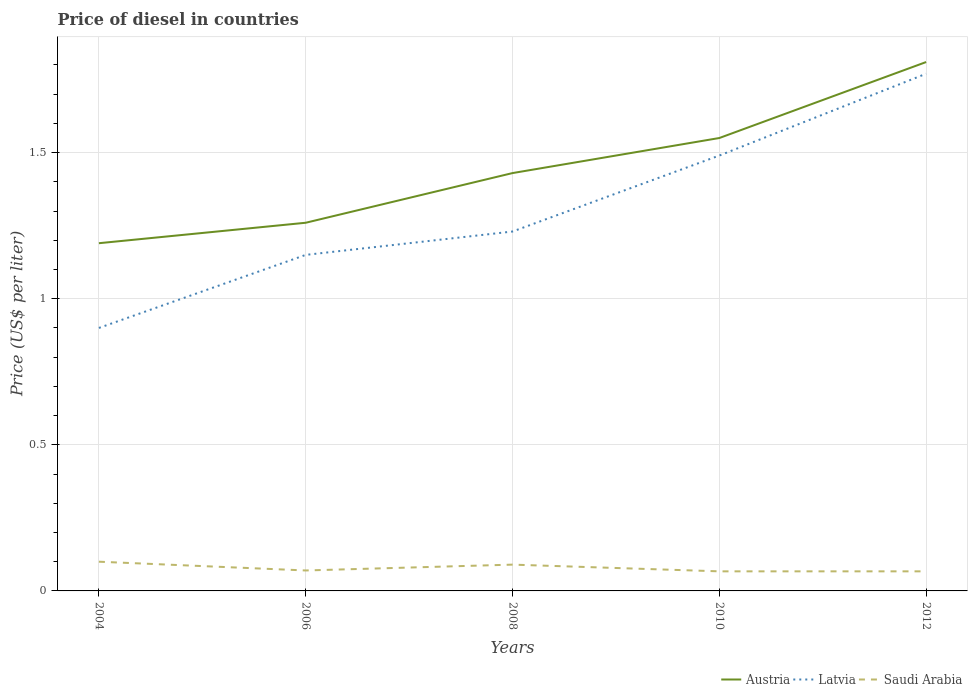How many different coloured lines are there?
Your response must be concise. 3. Does the line corresponding to Austria intersect with the line corresponding to Latvia?
Your answer should be compact. No. Is the number of lines equal to the number of legend labels?
Provide a succinct answer. Yes. Across all years, what is the maximum price of diesel in Saudi Arabia?
Make the answer very short. 0.07. In which year was the price of diesel in Latvia maximum?
Keep it short and to the point. 2004. What is the total price of diesel in Austria in the graph?
Your answer should be compact. -0.62. What is the difference between the highest and the second highest price of diesel in Saudi Arabia?
Offer a terse response. 0.03. What is the difference between the highest and the lowest price of diesel in Austria?
Your answer should be compact. 2. Is the price of diesel in Latvia strictly greater than the price of diesel in Austria over the years?
Offer a terse response. Yes. How many lines are there?
Your answer should be very brief. 3. What is the difference between two consecutive major ticks on the Y-axis?
Offer a terse response. 0.5. Are the values on the major ticks of Y-axis written in scientific E-notation?
Your response must be concise. No. Does the graph contain grids?
Offer a very short reply. Yes. Where does the legend appear in the graph?
Ensure brevity in your answer.  Bottom right. What is the title of the graph?
Provide a succinct answer. Price of diesel in countries. What is the label or title of the Y-axis?
Provide a succinct answer. Price (US$ per liter). What is the Price (US$ per liter) in Austria in 2004?
Your answer should be very brief. 1.19. What is the Price (US$ per liter) in Saudi Arabia in 2004?
Provide a succinct answer. 0.1. What is the Price (US$ per liter) in Austria in 2006?
Your answer should be very brief. 1.26. What is the Price (US$ per liter) of Latvia in 2006?
Keep it short and to the point. 1.15. What is the Price (US$ per liter) of Saudi Arabia in 2006?
Make the answer very short. 0.07. What is the Price (US$ per liter) in Austria in 2008?
Offer a very short reply. 1.43. What is the Price (US$ per liter) of Latvia in 2008?
Offer a very short reply. 1.23. What is the Price (US$ per liter) in Saudi Arabia in 2008?
Your answer should be very brief. 0.09. What is the Price (US$ per liter) of Austria in 2010?
Offer a very short reply. 1.55. What is the Price (US$ per liter) in Latvia in 2010?
Offer a very short reply. 1.49. What is the Price (US$ per liter) in Saudi Arabia in 2010?
Offer a very short reply. 0.07. What is the Price (US$ per liter) in Austria in 2012?
Provide a short and direct response. 1.81. What is the Price (US$ per liter) of Latvia in 2012?
Your response must be concise. 1.77. What is the Price (US$ per liter) of Saudi Arabia in 2012?
Your answer should be very brief. 0.07. Across all years, what is the maximum Price (US$ per liter) of Austria?
Your answer should be compact. 1.81. Across all years, what is the maximum Price (US$ per liter) of Latvia?
Your response must be concise. 1.77. Across all years, what is the minimum Price (US$ per liter) of Austria?
Provide a succinct answer. 1.19. Across all years, what is the minimum Price (US$ per liter) of Saudi Arabia?
Provide a short and direct response. 0.07. What is the total Price (US$ per liter) in Austria in the graph?
Offer a terse response. 7.24. What is the total Price (US$ per liter) in Latvia in the graph?
Make the answer very short. 6.54. What is the total Price (US$ per liter) of Saudi Arabia in the graph?
Your answer should be compact. 0.39. What is the difference between the Price (US$ per liter) of Austria in 2004 and that in 2006?
Your response must be concise. -0.07. What is the difference between the Price (US$ per liter) of Saudi Arabia in 2004 and that in 2006?
Your response must be concise. 0.03. What is the difference between the Price (US$ per liter) in Austria in 2004 and that in 2008?
Give a very brief answer. -0.24. What is the difference between the Price (US$ per liter) of Latvia in 2004 and that in 2008?
Keep it short and to the point. -0.33. What is the difference between the Price (US$ per liter) in Saudi Arabia in 2004 and that in 2008?
Ensure brevity in your answer.  0.01. What is the difference between the Price (US$ per liter) in Austria in 2004 and that in 2010?
Your answer should be compact. -0.36. What is the difference between the Price (US$ per liter) in Latvia in 2004 and that in 2010?
Give a very brief answer. -0.59. What is the difference between the Price (US$ per liter) in Saudi Arabia in 2004 and that in 2010?
Ensure brevity in your answer.  0.03. What is the difference between the Price (US$ per liter) of Austria in 2004 and that in 2012?
Make the answer very short. -0.62. What is the difference between the Price (US$ per liter) of Latvia in 2004 and that in 2012?
Offer a terse response. -0.87. What is the difference between the Price (US$ per liter) in Saudi Arabia in 2004 and that in 2012?
Give a very brief answer. 0.03. What is the difference between the Price (US$ per liter) in Austria in 2006 and that in 2008?
Ensure brevity in your answer.  -0.17. What is the difference between the Price (US$ per liter) in Latvia in 2006 and that in 2008?
Keep it short and to the point. -0.08. What is the difference between the Price (US$ per liter) of Saudi Arabia in 2006 and that in 2008?
Your answer should be very brief. -0.02. What is the difference between the Price (US$ per liter) of Austria in 2006 and that in 2010?
Offer a very short reply. -0.29. What is the difference between the Price (US$ per liter) of Latvia in 2006 and that in 2010?
Your response must be concise. -0.34. What is the difference between the Price (US$ per liter) in Saudi Arabia in 2006 and that in 2010?
Your answer should be very brief. 0. What is the difference between the Price (US$ per liter) of Austria in 2006 and that in 2012?
Give a very brief answer. -0.55. What is the difference between the Price (US$ per liter) of Latvia in 2006 and that in 2012?
Your answer should be compact. -0.62. What is the difference between the Price (US$ per liter) in Saudi Arabia in 2006 and that in 2012?
Offer a very short reply. 0. What is the difference between the Price (US$ per liter) in Austria in 2008 and that in 2010?
Your answer should be compact. -0.12. What is the difference between the Price (US$ per liter) in Latvia in 2008 and that in 2010?
Ensure brevity in your answer.  -0.26. What is the difference between the Price (US$ per liter) of Saudi Arabia in 2008 and that in 2010?
Ensure brevity in your answer.  0.02. What is the difference between the Price (US$ per liter) of Austria in 2008 and that in 2012?
Make the answer very short. -0.38. What is the difference between the Price (US$ per liter) in Latvia in 2008 and that in 2012?
Provide a succinct answer. -0.54. What is the difference between the Price (US$ per liter) of Saudi Arabia in 2008 and that in 2012?
Keep it short and to the point. 0.02. What is the difference between the Price (US$ per liter) in Austria in 2010 and that in 2012?
Make the answer very short. -0.26. What is the difference between the Price (US$ per liter) of Latvia in 2010 and that in 2012?
Provide a succinct answer. -0.28. What is the difference between the Price (US$ per liter) in Austria in 2004 and the Price (US$ per liter) in Latvia in 2006?
Your response must be concise. 0.04. What is the difference between the Price (US$ per liter) in Austria in 2004 and the Price (US$ per liter) in Saudi Arabia in 2006?
Provide a succinct answer. 1.12. What is the difference between the Price (US$ per liter) in Latvia in 2004 and the Price (US$ per liter) in Saudi Arabia in 2006?
Make the answer very short. 0.83. What is the difference between the Price (US$ per liter) of Austria in 2004 and the Price (US$ per liter) of Latvia in 2008?
Give a very brief answer. -0.04. What is the difference between the Price (US$ per liter) of Austria in 2004 and the Price (US$ per liter) of Saudi Arabia in 2008?
Keep it short and to the point. 1.1. What is the difference between the Price (US$ per liter) in Latvia in 2004 and the Price (US$ per liter) in Saudi Arabia in 2008?
Your answer should be very brief. 0.81. What is the difference between the Price (US$ per liter) in Austria in 2004 and the Price (US$ per liter) in Saudi Arabia in 2010?
Offer a terse response. 1.12. What is the difference between the Price (US$ per liter) of Latvia in 2004 and the Price (US$ per liter) of Saudi Arabia in 2010?
Make the answer very short. 0.83. What is the difference between the Price (US$ per liter) in Austria in 2004 and the Price (US$ per liter) in Latvia in 2012?
Give a very brief answer. -0.58. What is the difference between the Price (US$ per liter) of Austria in 2004 and the Price (US$ per liter) of Saudi Arabia in 2012?
Provide a short and direct response. 1.12. What is the difference between the Price (US$ per liter) of Latvia in 2004 and the Price (US$ per liter) of Saudi Arabia in 2012?
Keep it short and to the point. 0.83. What is the difference between the Price (US$ per liter) in Austria in 2006 and the Price (US$ per liter) in Latvia in 2008?
Make the answer very short. 0.03. What is the difference between the Price (US$ per liter) in Austria in 2006 and the Price (US$ per liter) in Saudi Arabia in 2008?
Ensure brevity in your answer.  1.17. What is the difference between the Price (US$ per liter) of Latvia in 2006 and the Price (US$ per liter) of Saudi Arabia in 2008?
Ensure brevity in your answer.  1.06. What is the difference between the Price (US$ per liter) of Austria in 2006 and the Price (US$ per liter) of Latvia in 2010?
Ensure brevity in your answer.  -0.23. What is the difference between the Price (US$ per liter) in Austria in 2006 and the Price (US$ per liter) in Saudi Arabia in 2010?
Provide a succinct answer. 1.19. What is the difference between the Price (US$ per liter) in Latvia in 2006 and the Price (US$ per liter) in Saudi Arabia in 2010?
Provide a short and direct response. 1.08. What is the difference between the Price (US$ per liter) of Austria in 2006 and the Price (US$ per liter) of Latvia in 2012?
Provide a succinct answer. -0.51. What is the difference between the Price (US$ per liter) in Austria in 2006 and the Price (US$ per liter) in Saudi Arabia in 2012?
Provide a short and direct response. 1.19. What is the difference between the Price (US$ per liter) of Latvia in 2006 and the Price (US$ per liter) of Saudi Arabia in 2012?
Give a very brief answer. 1.08. What is the difference between the Price (US$ per liter) of Austria in 2008 and the Price (US$ per liter) of Latvia in 2010?
Ensure brevity in your answer.  -0.06. What is the difference between the Price (US$ per liter) in Austria in 2008 and the Price (US$ per liter) in Saudi Arabia in 2010?
Give a very brief answer. 1.36. What is the difference between the Price (US$ per liter) of Latvia in 2008 and the Price (US$ per liter) of Saudi Arabia in 2010?
Offer a terse response. 1.16. What is the difference between the Price (US$ per liter) of Austria in 2008 and the Price (US$ per liter) of Latvia in 2012?
Your response must be concise. -0.34. What is the difference between the Price (US$ per liter) in Austria in 2008 and the Price (US$ per liter) in Saudi Arabia in 2012?
Offer a very short reply. 1.36. What is the difference between the Price (US$ per liter) in Latvia in 2008 and the Price (US$ per liter) in Saudi Arabia in 2012?
Your answer should be compact. 1.16. What is the difference between the Price (US$ per liter) in Austria in 2010 and the Price (US$ per liter) in Latvia in 2012?
Offer a terse response. -0.22. What is the difference between the Price (US$ per liter) of Austria in 2010 and the Price (US$ per liter) of Saudi Arabia in 2012?
Offer a terse response. 1.48. What is the difference between the Price (US$ per liter) in Latvia in 2010 and the Price (US$ per liter) in Saudi Arabia in 2012?
Your answer should be compact. 1.42. What is the average Price (US$ per liter) in Austria per year?
Offer a very short reply. 1.45. What is the average Price (US$ per liter) of Latvia per year?
Provide a succinct answer. 1.31. What is the average Price (US$ per liter) in Saudi Arabia per year?
Your answer should be compact. 0.08. In the year 2004, what is the difference between the Price (US$ per liter) of Austria and Price (US$ per liter) of Latvia?
Make the answer very short. 0.29. In the year 2004, what is the difference between the Price (US$ per liter) in Austria and Price (US$ per liter) in Saudi Arabia?
Make the answer very short. 1.09. In the year 2006, what is the difference between the Price (US$ per liter) of Austria and Price (US$ per liter) of Latvia?
Offer a very short reply. 0.11. In the year 2006, what is the difference between the Price (US$ per liter) in Austria and Price (US$ per liter) in Saudi Arabia?
Your response must be concise. 1.19. In the year 2008, what is the difference between the Price (US$ per liter) of Austria and Price (US$ per liter) of Saudi Arabia?
Provide a succinct answer. 1.34. In the year 2008, what is the difference between the Price (US$ per liter) in Latvia and Price (US$ per liter) in Saudi Arabia?
Give a very brief answer. 1.14. In the year 2010, what is the difference between the Price (US$ per liter) of Austria and Price (US$ per liter) of Latvia?
Offer a very short reply. 0.06. In the year 2010, what is the difference between the Price (US$ per liter) in Austria and Price (US$ per liter) in Saudi Arabia?
Provide a short and direct response. 1.48. In the year 2010, what is the difference between the Price (US$ per liter) in Latvia and Price (US$ per liter) in Saudi Arabia?
Offer a terse response. 1.42. In the year 2012, what is the difference between the Price (US$ per liter) of Austria and Price (US$ per liter) of Latvia?
Make the answer very short. 0.04. In the year 2012, what is the difference between the Price (US$ per liter) in Austria and Price (US$ per liter) in Saudi Arabia?
Ensure brevity in your answer.  1.74. In the year 2012, what is the difference between the Price (US$ per liter) in Latvia and Price (US$ per liter) in Saudi Arabia?
Make the answer very short. 1.7. What is the ratio of the Price (US$ per liter) in Latvia in 2004 to that in 2006?
Make the answer very short. 0.78. What is the ratio of the Price (US$ per liter) of Saudi Arabia in 2004 to that in 2006?
Offer a terse response. 1.43. What is the ratio of the Price (US$ per liter) in Austria in 2004 to that in 2008?
Your answer should be very brief. 0.83. What is the ratio of the Price (US$ per liter) of Latvia in 2004 to that in 2008?
Your answer should be compact. 0.73. What is the ratio of the Price (US$ per liter) in Austria in 2004 to that in 2010?
Provide a short and direct response. 0.77. What is the ratio of the Price (US$ per liter) in Latvia in 2004 to that in 2010?
Your answer should be compact. 0.6. What is the ratio of the Price (US$ per liter) of Saudi Arabia in 2004 to that in 2010?
Offer a very short reply. 1.49. What is the ratio of the Price (US$ per liter) of Austria in 2004 to that in 2012?
Your response must be concise. 0.66. What is the ratio of the Price (US$ per liter) of Latvia in 2004 to that in 2012?
Provide a succinct answer. 0.51. What is the ratio of the Price (US$ per liter) of Saudi Arabia in 2004 to that in 2012?
Your answer should be very brief. 1.49. What is the ratio of the Price (US$ per liter) in Austria in 2006 to that in 2008?
Your answer should be very brief. 0.88. What is the ratio of the Price (US$ per liter) of Latvia in 2006 to that in 2008?
Your answer should be compact. 0.94. What is the ratio of the Price (US$ per liter) of Austria in 2006 to that in 2010?
Provide a short and direct response. 0.81. What is the ratio of the Price (US$ per liter) in Latvia in 2006 to that in 2010?
Provide a succinct answer. 0.77. What is the ratio of the Price (US$ per liter) in Saudi Arabia in 2006 to that in 2010?
Your response must be concise. 1.04. What is the ratio of the Price (US$ per liter) in Austria in 2006 to that in 2012?
Your answer should be compact. 0.7. What is the ratio of the Price (US$ per liter) in Latvia in 2006 to that in 2012?
Your answer should be compact. 0.65. What is the ratio of the Price (US$ per liter) in Saudi Arabia in 2006 to that in 2012?
Your response must be concise. 1.04. What is the ratio of the Price (US$ per liter) in Austria in 2008 to that in 2010?
Offer a very short reply. 0.92. What is the ratio of the Price (US$ per liter) of Latvia in 2008 to that in 2010?
Your answer should be compact. 0.83. What is the ratio of the Price (US$ per liter) of Saudi Arabia in 2008 to that in 2010?
Keep it short and to the point. 1.34. What is the ratio of the Price (US$ per liter) of Austria in 2008 to that in 2012?
Your response must be concise. 0.79. What is the ratio of the Price (US$ per liter) of Latvia in 2008 to that in 2012?
Provide a succinct answer. 0.69. What is the ratio of the Price (US$ per liter) in Saudi Arabia in 2008 to that in 2012?
Offer a terse response. 1.34. What is the ratio of the Price (US$ per liter) in Austria in 2010 to that in 2012?
Your response must be concise. 0.86. What is the ratio of the Price (US$ per liter) of Latvia in 2010 to that in 2012?
Provide a short and direct response. 0.84. What is the ratio of the Price (US$ per liter) of Saudi Arabia in 2010 to that in 2012?
Your answer should be compact. 1. What is the difference between the highest and the second highest Price (US$ per liter) in Austria?
Provide a succinct answer. 0.26. What is the difference between the highest and the second highest Price (US$ per liter) in Latvia?
Offer a very short reply. 0.28. What is the difference between the highest and the second highest Price (US$ per liter) in Saudi Arabia?
Offer a very short reply. 0.01. What is the difference between the highest and the lowest Price (US$ per liter) of Austria?
Provide a short and direct response. 0.62. What is the difference between the highest and the lowest Price (US$ per liter) in Latvia?
Your response must be concise. 0.87. What is the difference between the highest and the lowest Price (US$ per liter) in Saudi Arabia?
Offer a terse response. 0.03. 